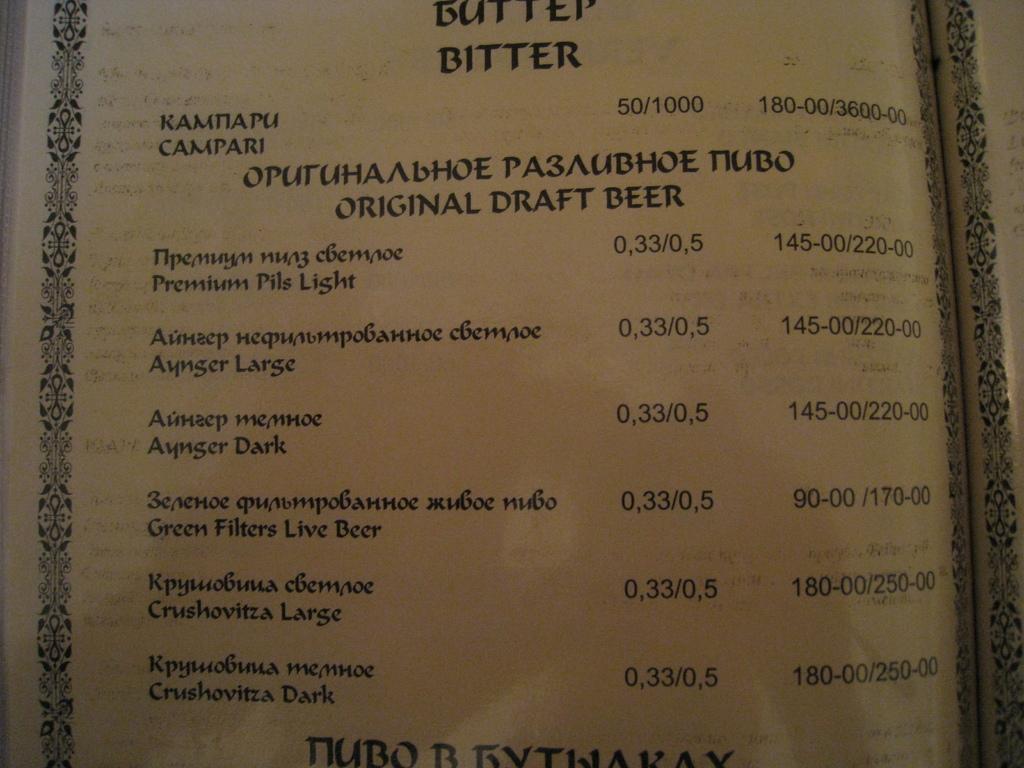What is being sold on this menu?
Your answer should be compact. Beer. What is the top word on the menu?
Provide a succinct answer. Bitter. 